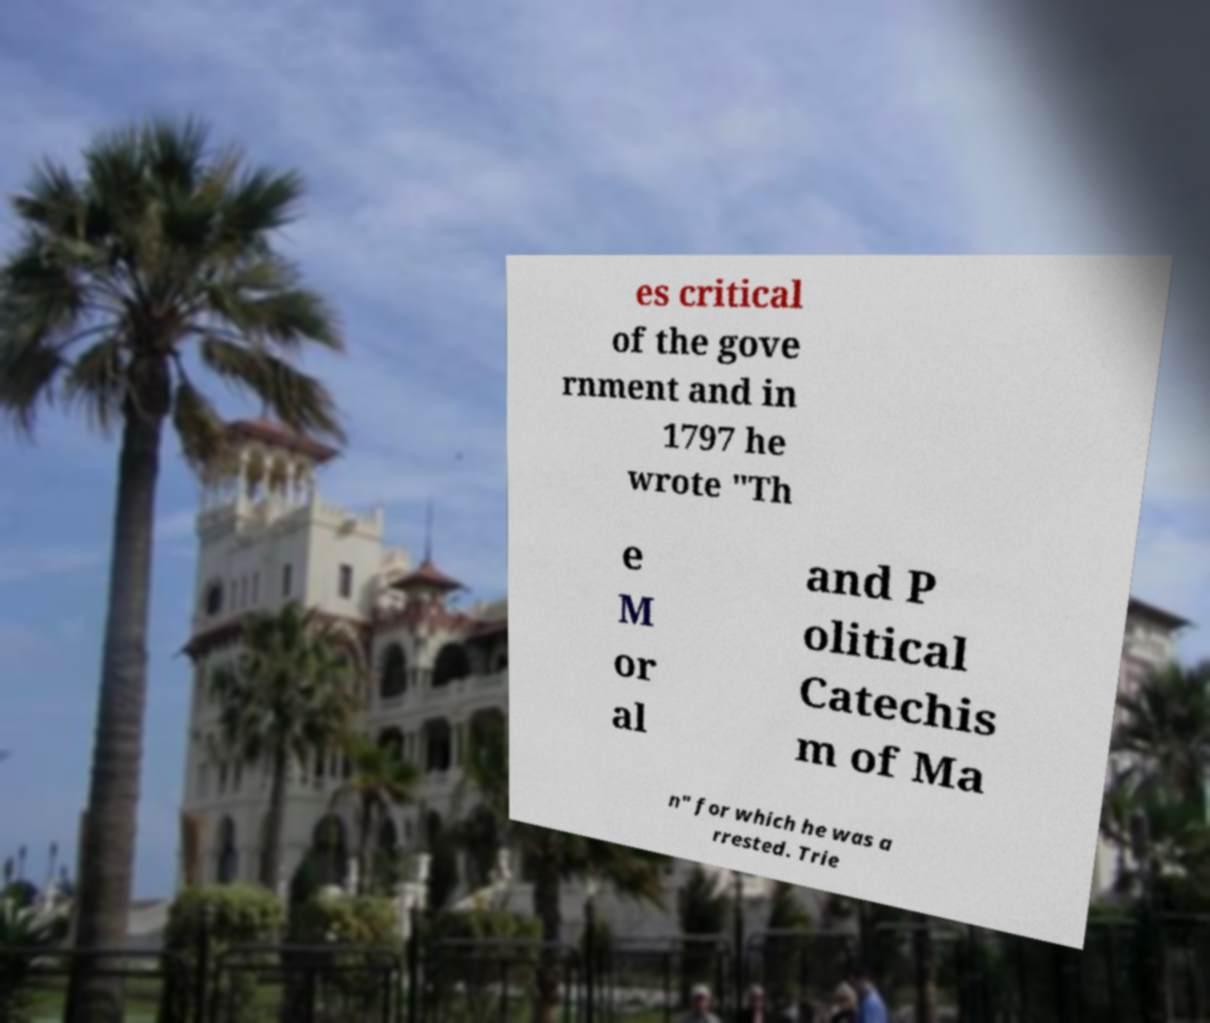Can you accurately transcribe the text from the provided image for me? es critical of the gove rnment and in 1797 he wrote "Th e M or al and P olitical Catechis m of Ma n" for which he was a rrested. Trie 